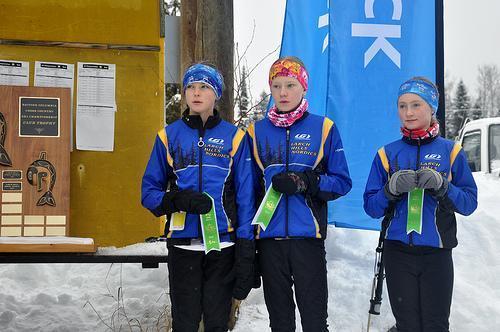How many people are in the picture?
Give a very brief answer. 3. 